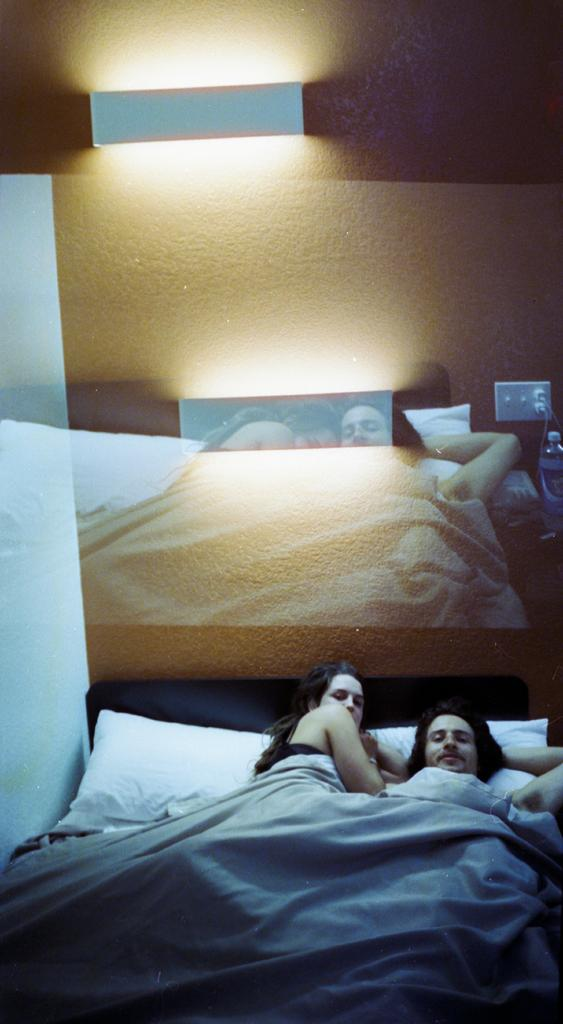What are the two people in the image doing? The two people in the image are sleeping on a white bed. Can you describe anything on the wall in the image? There is a picture on the wall. What type of lighting is present in the image? There is a white light fitted to the wall. What type of root can be seen growing from the bed in the image? There is no root growing from the bed in the image; it is a white bed with two people sleeping on it. 